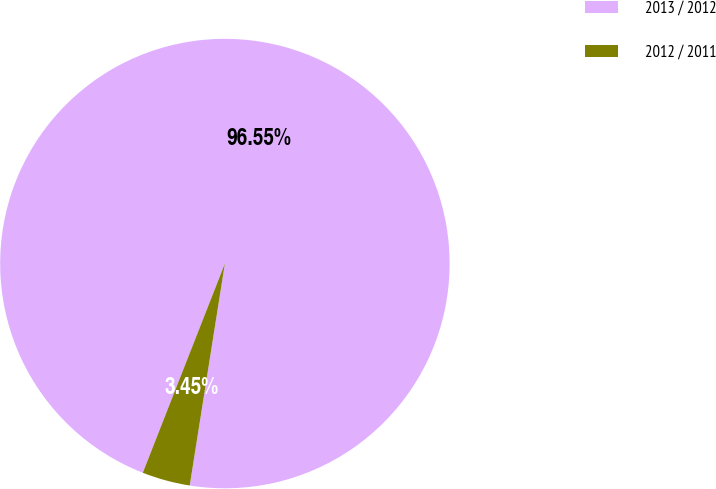Convert chart. <chart><loc_0><loc_0><loc_500><loc_500><pie_chart><fcel>2013 / 2012<fcel>2012 / 2011<nl><fcel>96.55%<fcel>3.45%<nl></chart> 